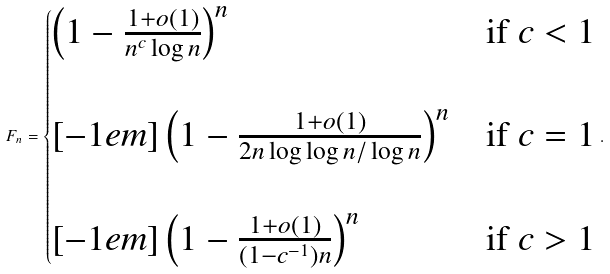<formula> <loc_0><loc_0><loc_500><loc_500>F _ { n } = \begin{cases} \left ( 1 - \frac { 1 + o ( 1 ) } { n ^ { c } \log n } \right ) ^ { n } & \text {if $c < 1$} \\ \\ [ - 1 e m ] \left ( 1 - \frac { 1 + o ( 1 ) } { 2 n \log \log n / \log n } \right ) ^ { n } & \text {if  $c=1$} \\ \\ [ - 1 e m ] \left ( 1 - \frac { 1 + o ( 1 ) } { ( 1 - c ^ { - 1 } ) n } \right ) ^ { n } & \text {if $c > 1$} \end{cases} .</formula> 